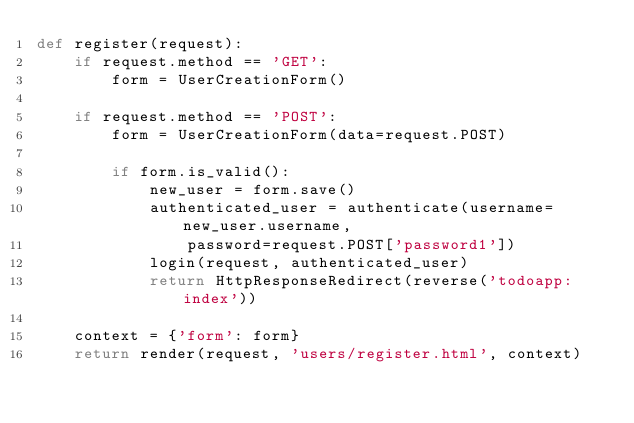<code> <loc_0><loc_0><loc_500><loc_500><_Python_>def register(request):
    if request.method == 'GET':
        form = UserCreationForm()
    
    if request.method == 'POST':
        form = UserCreationForm(data=request.POST)

        if form.is_valid():
            new_user = form.save()
            authenticated_user = authenticate(username=new_user.username,
                password=request.POST['password1'])
            login(request, authenticated_user)
            return HttpResponseRedirect(reverse('todoapp:index'))

    context = {'form': form}
    return render(request, 'users/register.html', context)
</code> 